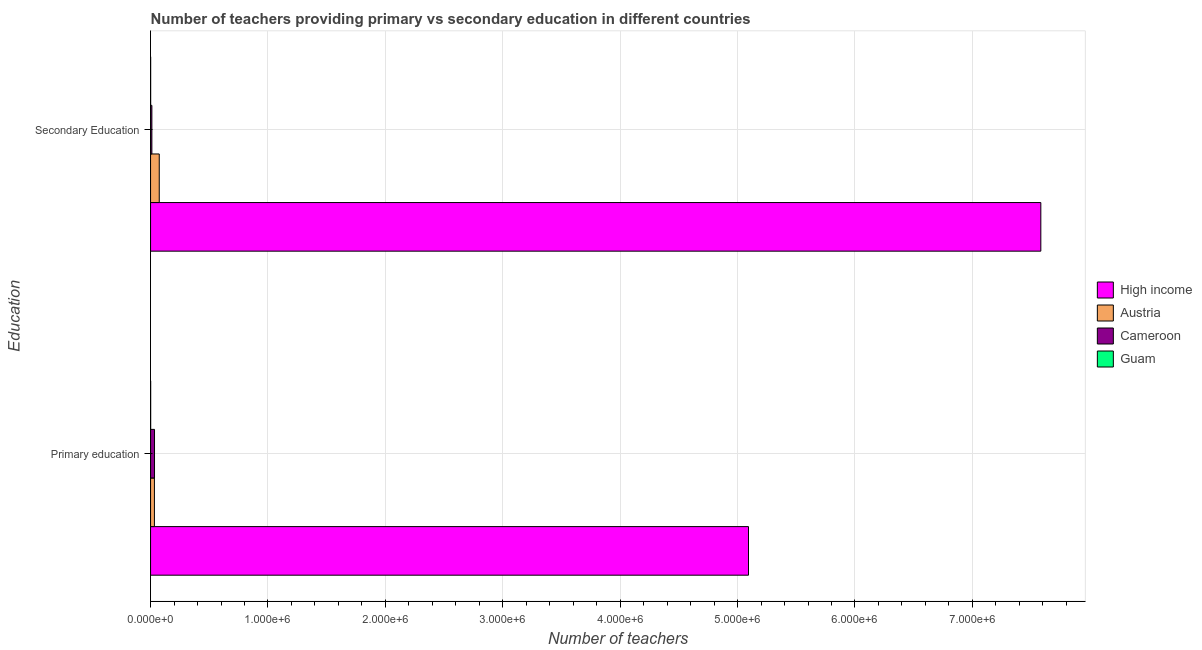How many groups of bars are there?
Provide a short and direct response. 2. How many bars are there on the 2nd tick from the bottom?
Your response must be concise. 4. What is the label of the 1st group of bars from the top?
Make the answer very short. Secondary Education. What is the number of primary teachers in Guam?
Offer a very short reply. 840. Across all countries, what is the maximum number of primary teachers?
Make the answer very short. 5.09e+06. Across all countries, what is the minimum number of primary teachers?
Keep it short and to the point. 840. In which country was the number of secondary teachers maximum?
Your response must be concise. High income. In which country was the number of secondary teachers minimum?
Keep it short and to the point. Guam. What is the total number of secondary teachers in the graph?
Provide a succinct answer. 7.67e+06. What is the difference between the number of primary teachers in Guam and that in High income?
Your answer should be very brief. -5.09e+06. What is the difference between the number of primary teachers in Guam and the number of secondary teachers in Austria?
Your response must be concise. -7.32e+04. What is the average number of secondary teachers per country?
Ensure brevity in your answer.  1.92e+06. What is the difference between the number of secondary teachers and number of primary teachers in High income?
Provide a succinct answer. 2.49e+06. In how many countries, is the number of primary teachers greater than 6200000 ?
Offer a terse response. 0. What is the ratio of the number of primary teachers in Guam to that in Austria?
Give a very brief answer. 0.03. What does the 2nd bar from the top in Secondary Education represents?
Offer a terse response. Cameroon. What does the 3rd bar from the bottom in Secondary Education represents?
Provide a succinct answer. Cameroon. Does the graph contain grids?
Your answer should be compact. Yes. How many legend labels are there?
Make the answer very short. 4. What is the title of the graph?
Give a very brief answer. Number of teachers providing primary vs secondary education in different countries. Does "Jordan" appear as one of the legend labels in the graph?
Provide a short and direct response. No. What is the label or title of the X-axis?
Your answer should be compact. Number of teachers. What is the label or title of the Y-axis?
Ensure brevity in your answer.  Education. What is the Number of teachers of High income in Primary education?
Your answer should be compact. 5.09e+06. What is the Number of teachers of Austria in Primary education?
Your answer should be very brief. 3.28e+04. What is the Number of teachers of Cameroon in Primary education?
Provide a succinct answer. 3.36e+04. What is the Number of teachers of Guam in Primary education?
Give a very brief answer. 840. What is the Number of teachers of High income in Secondary Education?
Your response must be concise. 7.58e+06. What is the Number of teachers in Austria in Secondary Education?
Your response must be concise. 7.40e+04. What is the Number of teachers in Cameroon in Secondary Education?
Your answer should be very brief. 1.11e+04. What is the Number of teachers of Guam in Secondary Education?
Provide a succinct answer. 794. Across all Education, what is the maximum Number of teachers in High income?
Ensure brevity in your answer.  7.58e+06. Across all Education, what is the maximum Number of teachers of Austria?
Your answer should be compact. 7.40e+04. Across all Education, what is the maximum Number of teachers in Cameroon?
Offer a very short reply. 3.36e+04. Across all Education, what is the maximum Number of teachers of Guam?
Provide a succinct answer. 840. Across all Education, what is the minimum Number of teachers of High income?
Your answer should be compact. 5.09e+06. Across all Education, what is the minimum Number of teachers of Austria?
Offer a terse response. 3.28e+04. Across all Education, what is the minimum Number of teachers in Cameroon?
Offer a very short reply. 1.11e+04. Across all Education, what is the minimum Number of teachers of Guam?
Provide a succinct answer. 794. What is the total Number of teachers in High income in the graph?
Ensure brevity in your answer.  1.27e+07. What is the total Number of teachers in Austria in the graph?
Provide a short and direct response. 1.07e+05. What is the total Number of teachers in Cameroon in the graph?
Make the answer very short. 4.47e+04. What is the total Number of teachers in Guam in the graph?
Your answer should be very brief. 1634. What is the difference between the Number of teachers in High income in Primary education and that in Secondary Education?
Make the answer very short. -2.49e+06. What is the difference between the Number of teachers in Austria in Primary education and that in Secondary Education?
Keep it short and to the point. -4.12e+04. What is the difference between the Number of teachers of Cameroon in Primary education and that in Secondary Education?
Offer a terse response. 2.25e+04. What is the difference between the Number of teachers in Guam in Primary education and that in Secondary Education?
Offer a terse response. 46. What is the difference between the Number of teachers in High income in Primary education and the Number of teachers in Austria in Secondary Education?
Provide a short and direct response. 5.02e+06. What is the difference between the Number of teachers of High income in Primary education and the Number of teachers of Cameroon in Secondary Education?
Provide a succinct answer. 5.08e+06. What is the difference between the Number of teachers in High income in Primary education and the Number of teachers in Guam in Secondary Education?
Offer a terse response. 5.09e+06. What is the difference between the Number of teachers of Austria in Primary education and the Number of teachers of Cameroon in Secondary Education?
Keep it short and to the point. 2.17e+04. What is the difference between the Number of teachers in Austria in Primary education and the Number of teachers in Guam in Secondary Education?
Your response must be concise. 3.20e+04. What is the difference between the Number of teachers in Cameroon in Primary education and the Number of teachers in Guam in Secondary Education?
Provide a short and direct response. 3.28e+04. What is the average Number of teachers of High income per Education?
Offer a very short reply. 6.34e+06. What is the average Number of teachers in Austria per Education?
Keep it short and to the point. 5.34e+04. What is the average Number of teachers of Cameroon per Education?
Keep it short and to the point. 2.23e+04. What is the average Number of teachers of Guam per Education?
Your response must be concise. 817. What is the difference between the Number of teachers of High income and Number of teachers of Austria in Primary education?
Your answer should be compact. 5.06e+06. What is the difference between the Number of teachers in High income and Number of teachers in Cameroon in Primary education?
Give a very brief answer. 5.06e+06. What is the difference between the Number of teachers in High income and Number of teachers in Guam in Primary education?
Provide a succinct answer. 5.09e+06. What is the difference between the Number of teachers in Austria and Number of teachers in Cameroon in Primary education?
Provide a succinct answer. -792. What is the difference between the Number of teachers in Austria and Number of teachers in Guam in Primary education?
Your answer should be compact. 3.20e+04. What is the difference between the Number of teachers in Cameroon and Number of teachers in Guam in Primary education?
Provide a succinct answer. 3.28e+04. What is the difference between the Number of teachers in High income and Number of teachers in Austria in Secondary Education?
Provide a succinct answer. 7.51e+06. What is the difference between the Number of teachers of High income and Number of teachers of Cameroon in Secondary Education?
Ensure brevity in your answer.  7.57e+06. What is the difference between the Number of teachers of High income and Number of teachers of Guam in Secondary Education?
Your answer should be compact. 7.58e+06. What is the difference between the Number of teachers of Austria and Number of teachers of Cameroon in Secondary Education?
Your answer should be compact. 6.29e+04. What is the difference between the Number of teachers in Austria and Number of teachers in Guam in Secondary Education?
Offer a very short reply. 7.32e+04. What is the difference between the Number of teachers of Cameroon and Number of teachers of Guam in Secondary Education?
Make the answer very short. 1.03e+04. What is the ratio of the Number of teachers of High income in Primary education to that in Secondary Education?
Offer a terse response. 0.67. What is the ratio of the Number of teachers of Austria in Primary education to that in Secondary Education?
Make the answer very short. 0.44. What is the ratio of the Number of teachers in Cameroon in Primary education to that in Secondary Education?
Give a very brief answer. 3.03. What is the ratio of the Number of teachers of Guam in Primary education to that in Secondary Education?
Provide a short and direct response. 1.06. What is the difference between the highest and the second highest Number of teachers of High income?
Ensure brevity in your answer.  2.49e+06. What is the difference between the highest and the second highest Number of teachers of Austria?
Give a very brief answer. 4.12e+04. What is the difference between the highest and the second highest Number of teachers of Cameroon?
Ensure brevity in your answer.  2.25e+04. What is the difference between the highest and the lowest Number of teachers of High income?
Give a very brief answer. 2.49e+06. What is the difference between the highest and the lowest Number of teachers in Austria?
Provide a succinct answer. 4.12e+04. What is the difference between the highest and the lowest Number of teachers in Cameroon?
Offer a very short reply. 2.25e+04. What is the difference between the highest and the lowest Number of teachers in Guam?
Keep it short and to the point. 46. 